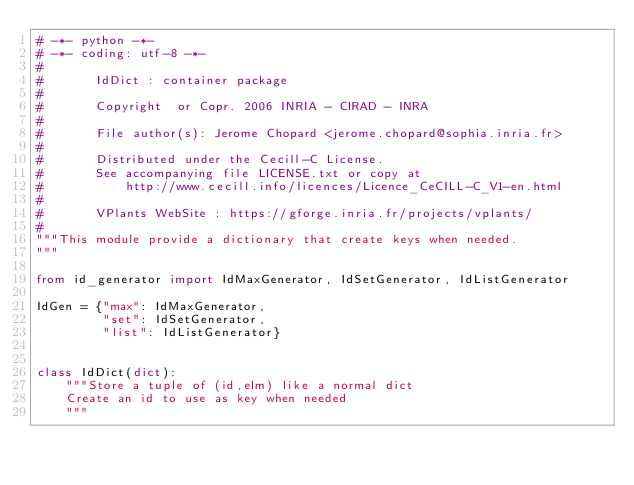Convert code to text. <code><loc_0><loc_0><loc_500><loc_500><_Python_># -*- python -*-
# -*- coding: utf-8 -*-
#
#       IdDict : container package
#
#       Copyright  or Copr. 2006 INRIA - CIRAD - INRA
#
#       File author(s): Jerome Chopard <jerome.chopard@sophia.inria.fr>
#
#       Distributed under the Cecill-C License.
#       See accompanying file LICENSE.txt or copy at
#           http://www.cecill.info/licences/Licence_CeCILL-C_V1-en.html
#
#       VPlants WebSite : https://gforge.inria.fr/projects/vplants/
#
"""This module provide a dictionary that create keys when needed.
"""

from id_generator import IdMaxGenerator, IdSetGenerator, IdListGenerator

IdGen = {"max": IdMaxGenerator,
         "set": IdSetGenerator,
         "list": IdListGenerator}


class IdDict(dict):
    """Store a tuple of (id,elm) like a normal dict
    Create an id to use as key when needed
    """
</code> 